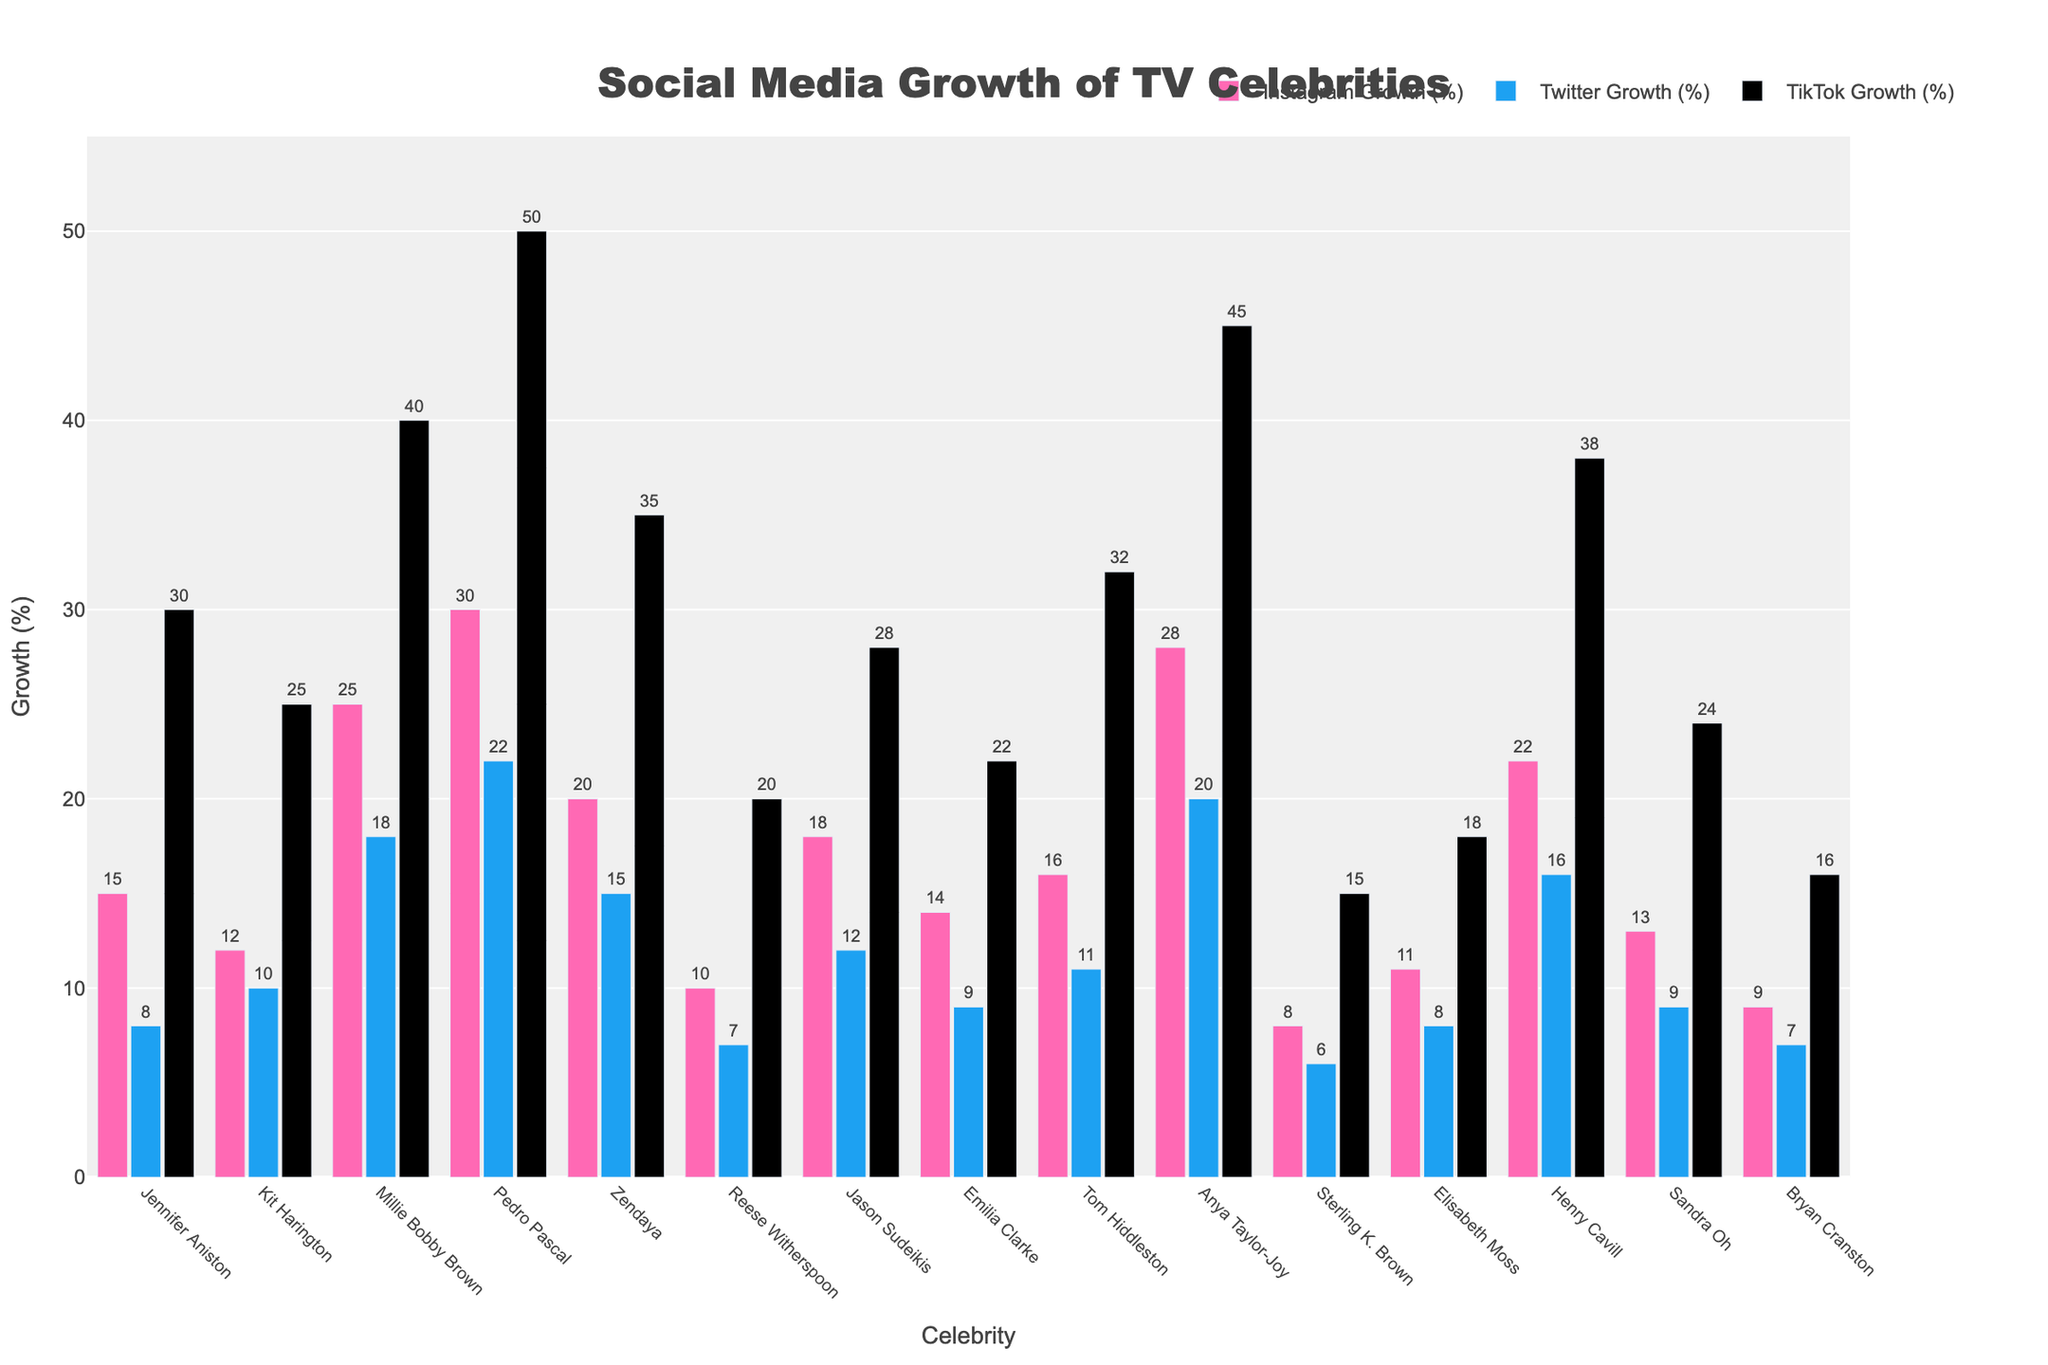Which celebrity had the highest Instagram growth percentage last year? The tallest pink bar in the chart represents the Instagram growth. By looking at the chart, we can see that Pedro Pascal had the highest Instagram growth at 30%.
Answer: Pedro Pascal Which platform saw the highest growth percentage for Anya Taylor-Joy? To determine this, observe the three bars associated with Anya Taylor-Joy. The black bar indicating TikTok shows the highest growth at 45%.
Answer: TikTok Compare the Twitter growth percentages of Kit Harington and Henry Cavill. Which one is higher? Examine the blue bars for both celebrities. Kit Harington has a Twitter growth of 10%, while Henry Cavill has a Twitter growth of 16%. Henry Cavill's growth is higher.
Answer: Henry Cavill What is the total social media growth percentage across all platforms for Millie Bobby Brown? Add the growth percentages for Instagram (25%), Twitter (18%), and TikTok (40%). The total is 25 + 18 + 40 = 83%.
Answer: 83% Among the celebrities, who had the lowest TikTok growth and what was the percentage? The shortest black bar in the TikTok section represents the lowest growth. Sterling K. Brown had the lowest TikTok growth at 15%.
Answer: Sterling K. Brown Find the difference in TikTok growth between Zendaya and Jason Sudeikis. Zendaya's TikTok growth is 35%, and Jason Sudeikis' is 28%. The difference is 35 - 28 = 7%.
Answer: 7% What is the average growth percentage on Instagram for all celebrities listed? Sum up all the Instagram growth percentages (15+12+25+30+20+10+18+14+16+28+8+11+22+13+9 = 246) and divide by the number of celebrities (15). The average is 246 / 15 = 16.4%.
Answer: 16.4% Compare Zendaya's Twitter and TikTok growth percentages. How much higher is her TikTok growth? Zendaya's Twitter growth is 15%, and her TikTok growth is 35%. The difference is 35 - 15 = 20%.
Answer: 20% Which celebrity had the closest Instagram and Twitter growth percentages and what are those percentages? By checking the pink and blue bars for each celebrity, we see that Reese Witherspoon had close percentages: Instagram growth at 10% and Twitter growth at 7%.
Answer: Reese Witherspoon, 10% Instagram, 7% Twitter What is the combined growth percentage for all platforms for Jennifer Aniston? Sum the growth percentages for Instagram (15%), Twitter (8%), and TikTok (30%). The total is 15 + 8 + 30 = 53%.
Answer: 53% 